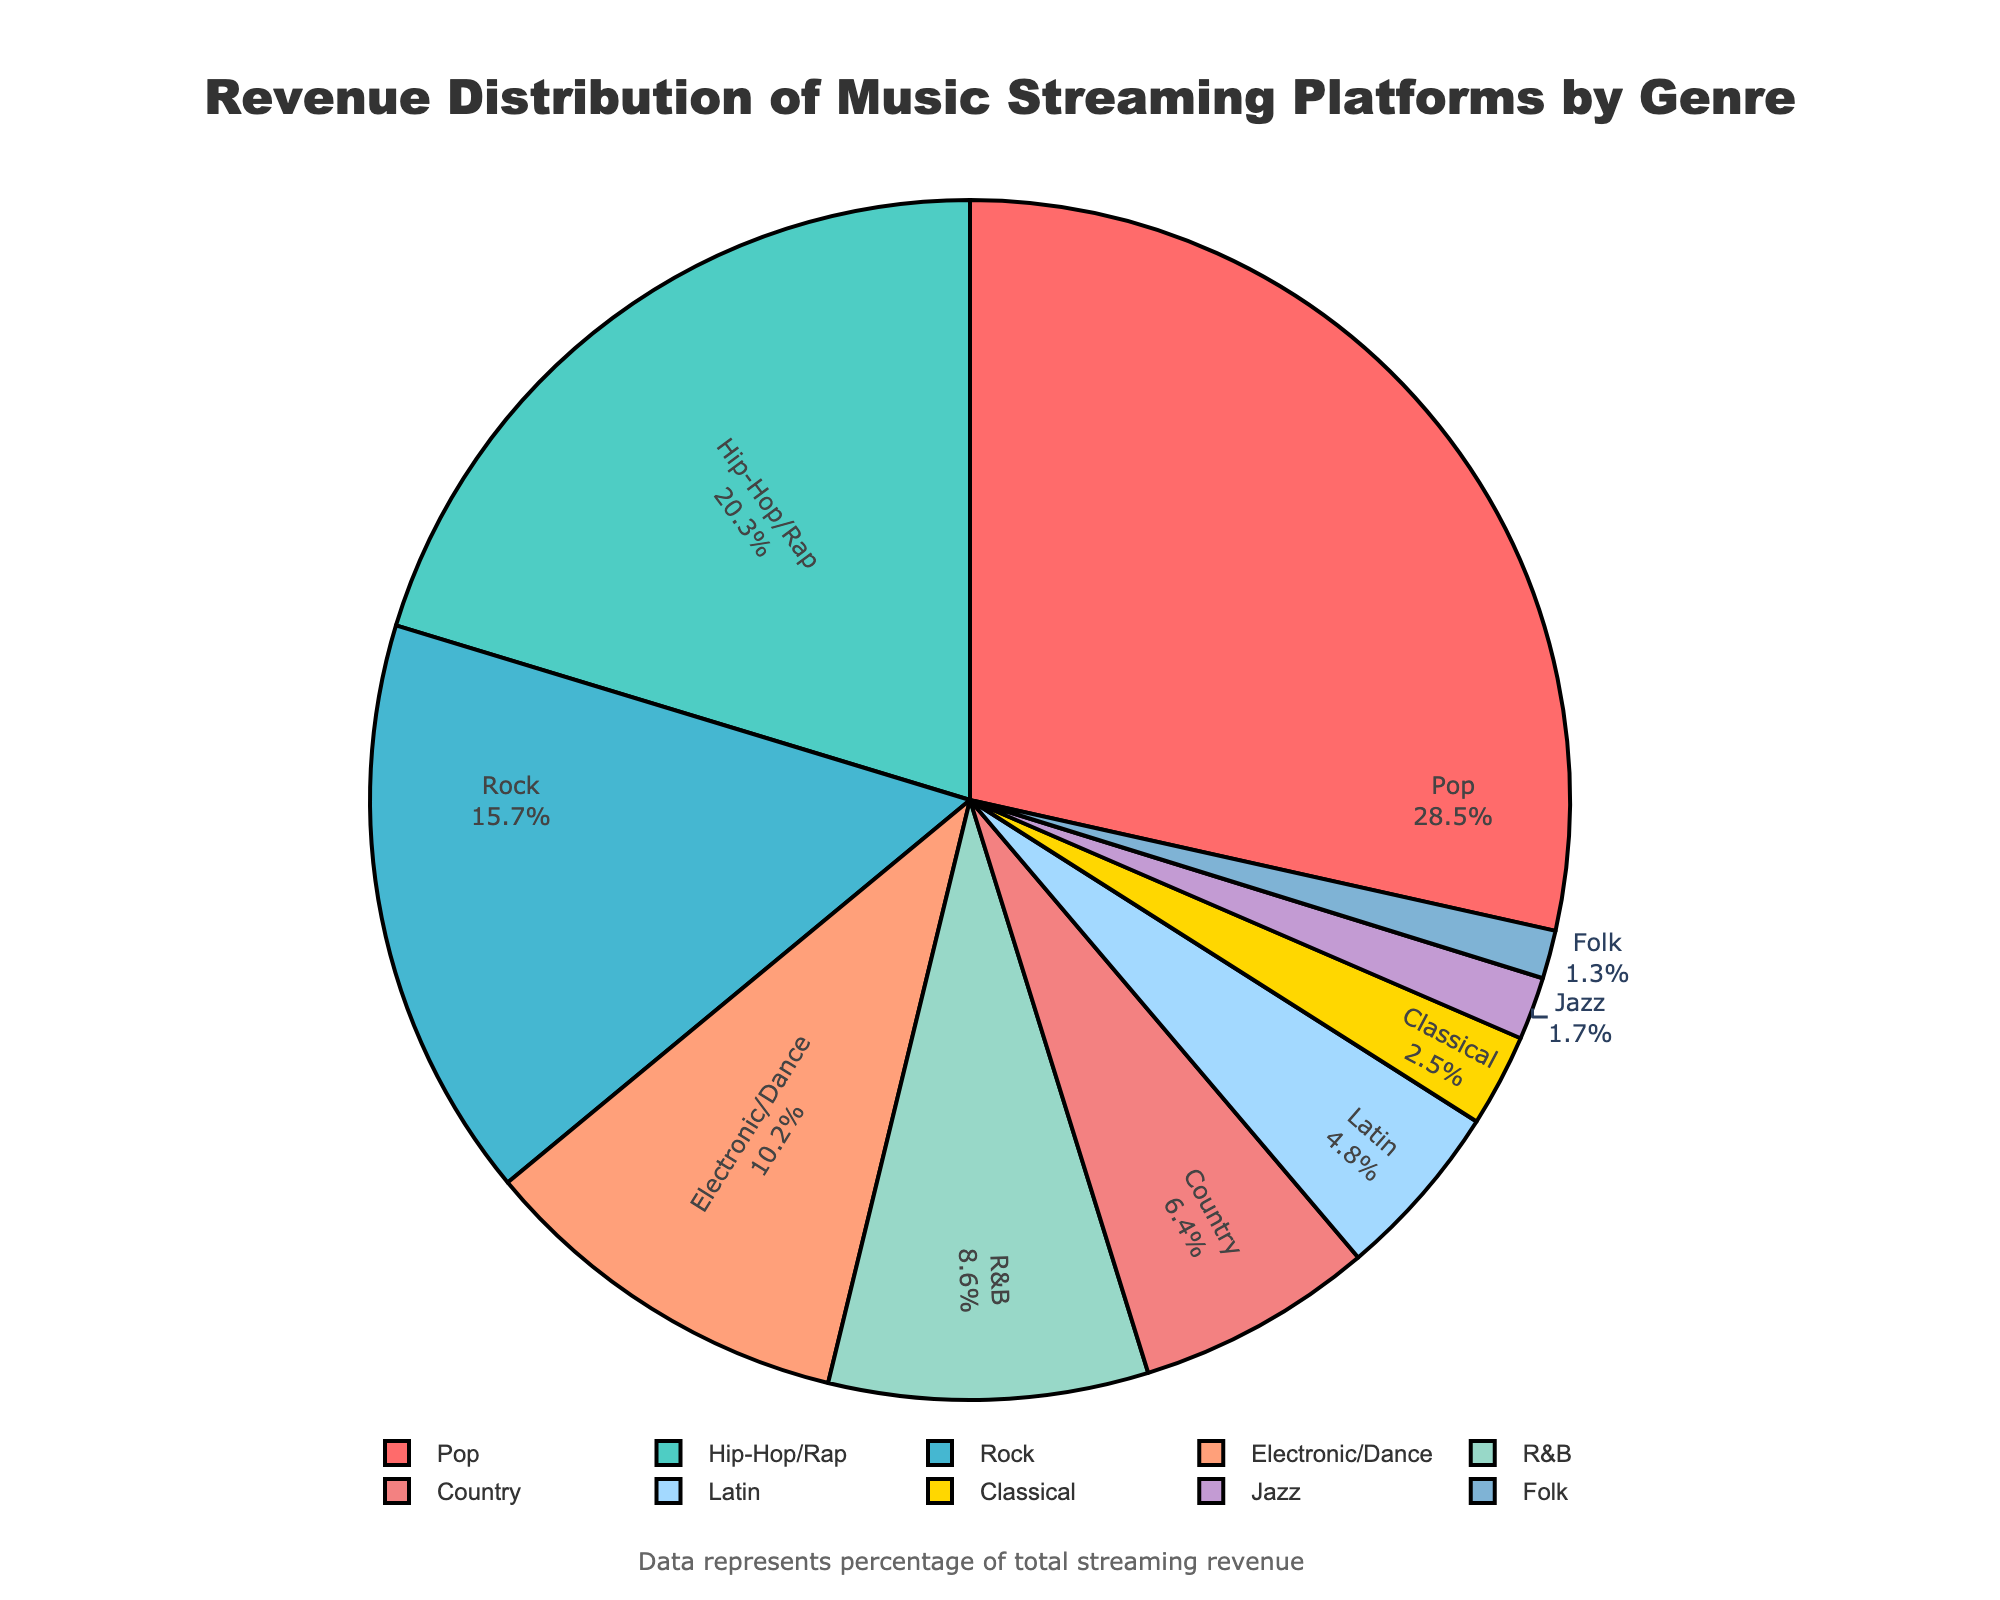What genre has the highest revenue percentage? From the pie chart, the size of the slices represents the revenue percentage contributions. The largest slice belongs to Pop.
Answer: Pop Which genre has a greater revenue percentage, Hip-Hop/Rap or Rock? By comparing the slices, Hip-Hop/Rap has a 20.3% revenue share, and Rock has 15.7%. Hip-Hop/Rap's slice is larger than Rock's slice.
Answer: Hip-Hop/Rap How much more revenue percentage does Pop have compared to Classical? Pop has a 28.5% revenue share and Classical has 2.5%. The difference is calculated as 28.5% - 2.5%.
Answer: 26.0% Which genres together make up just over half (greater than 50%) of the total revenue? Summing up the percentages from the largest slices until reaching over 50%: Pop (28.5%) + Hip-Hop/Rap (20.3%) = 48.8%. Adding the next genre, Rock (15.7%), total becomes 48.8% + 15.7% = 64.5%.
Answer: Pop, Hip-Hop/Rap, Rock What is the sum of the revenue percentages of Electronic/Dance and Classical? The revenue percentage of Electronic/Dance is 10.2% and Classical is 2.5%. Adding them together gives 10.2% + 2.5%.
Answer: 12.7% Among Jazz and Folk, which genre has lower revenue, and what is the difference in their revenue percentages? Jazz has a 1.7% revenue share, and Folk has 1.3%. Jazz's slice is slightly larger than Folk's slice. The difference is 1.7% - 1.3%.
Answer: Folk, 0.4% List the genres with a revenue percentage lower than 5%. The slices representing revenue percentages lower than 5% are: Latin (4.8%), Classical (2.5%), Jazz (1.7%), and Folk (1.3%).
Answer: Latin, Classical, Jazz, Folk How does the revenue percentage of R&B compare to Country? R&B has an 8.6% revenue share, and Country has 6.4%. R&B’s slice is larger than Country’s.
Answer: R&B If the total revenue was $100 million, how much revenue did the Rock genre contribute? Rock’s percentage is 15.7%. Calculating the revenue: (15.7 / 100) * $100 million.
Answer: $15.7 million 